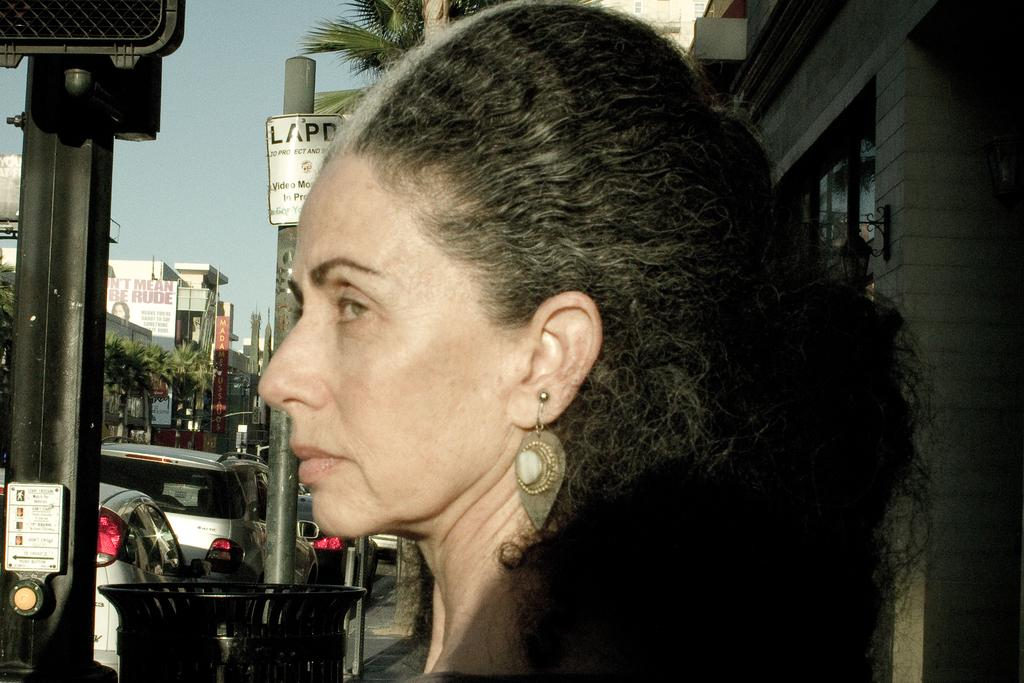Who or what is the main subject in the image? There is a person in the image. What can be seen in the background of the image? There are vehicles, stalls, trees, buildings, and poles in the background of the image. What is the color of the sky in the image? The sky is blue in color. How much tax is being paid by the person in the image? There is no information about taxes in the image, as it focuses on the person and the background elements. 